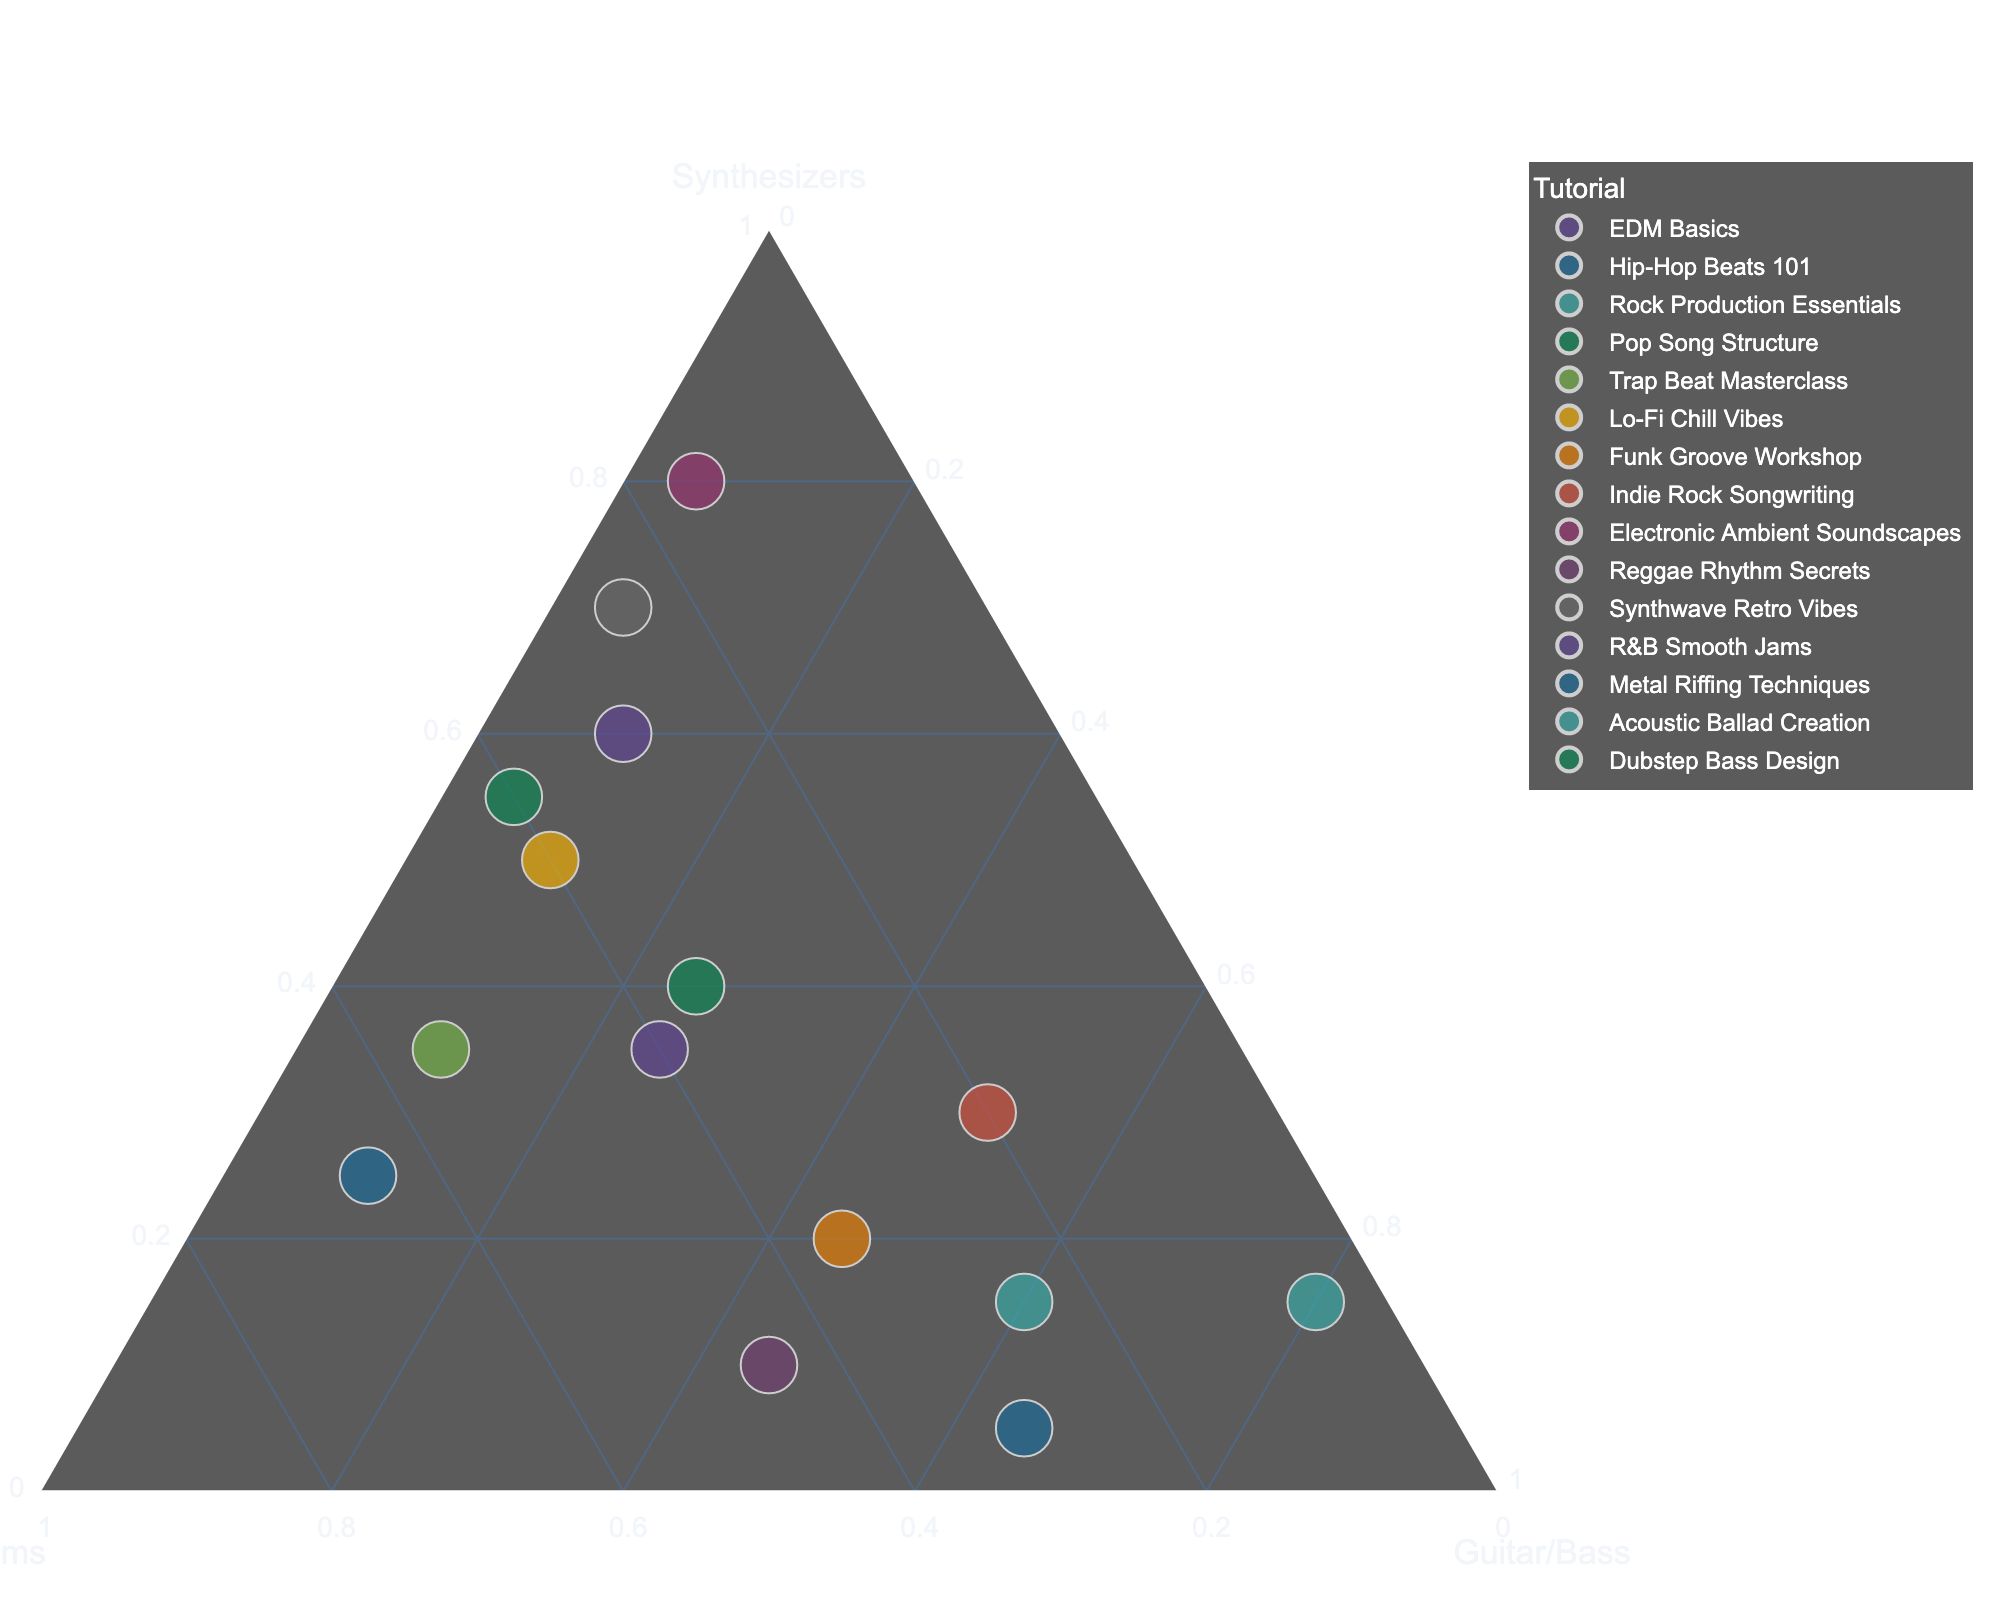What is the title of the figure? The title is usually displayed at the top of the plot and indicates the main focus of the visualized data.
Answer: GarageBand Instrument Usage in Tutorial Videos How many tutorials have Synthesizers as the predominant instrument? By observing the ternary plot, count the data points that are positioned closer to the Synthesizers vertex. There are three predominant clusters around the Synthesizers area: "Electronic Ambient Soundscapes," "Synthwave Retro Vibes," and "EDM Basics."
Answer: 3 Which tutorial has the highest percentage of Guitar/Bass usage? Locate the data points positioned closest to the Guitar/Bass vertex. "Acoustic Ballad Creation" at (15, 5, 80) is the closest.
Answer: Acoustic Ballad Creation Between "Trap Beat Masterclass" and "R&B Smooth Jams", which tutorial has a higher percentage of Drums usage? Compare the positions of both points relative to the Drums vertex. "Trap Beat Masterclass" is plotted at (35, 55, 10) and "R&B Smooth Jams" at (35, 40, 25). "Trap Beat Masterclass" has a higher percentage of Drums usage.
Answer: Trap Beat Masterclass What are the approximate coordinates for "Hip-Hop Beats 101"? Identify the position of the "Hip-Hop Beats 101" point in the ternary plot. It's found at (25, 65, 10) indicating the percentages of Synthesizers, Drums, and Guitar/Bass respectively.
Answer: (25, 65, 10) Which tutorial falls more towards equal usage of Drums and Guitar/Bass? Look for a point located roughly midway between the Drums and Guitar/Bass vertices. "Reggae Rhythm Secrets" at (10, 45, 45) is positioned close to an equal split.
Answer: Reggae Rhythm Secrets What is the combined percentage of Synthesizers and Drums for "Lo-Fi Chill Vibes"? Sum the percentages of Synthesizers and Drums for "Lo-Fi Chill Vibes" located at (50, 40, 10).
Answer: 90 Which tutorial has the least usage of Synthesizers? Look for the point farthest from the Synthesizers vertex. "Metal Riffing Techniques" at (5, 30, 65) uses Synthesizers the least.
Answer: Metal Riffing Techniques Which tutorial uses Synthesizers and Guitar/Bass in equal proportions? Locate the point where Synthesizers and Guitar/Bass percentages are the same. "Funk Groove Workshop" shows this balance with (20, 35, 45).
Answer: Funk Groove Workshop What is the overall spread of Synthesizer usage across all tutorials? Observe the range of values plotted along the Synthesizers axis, from the lowest to the highest point. The values range from 5 to 80.
Answer: 5 to 80 